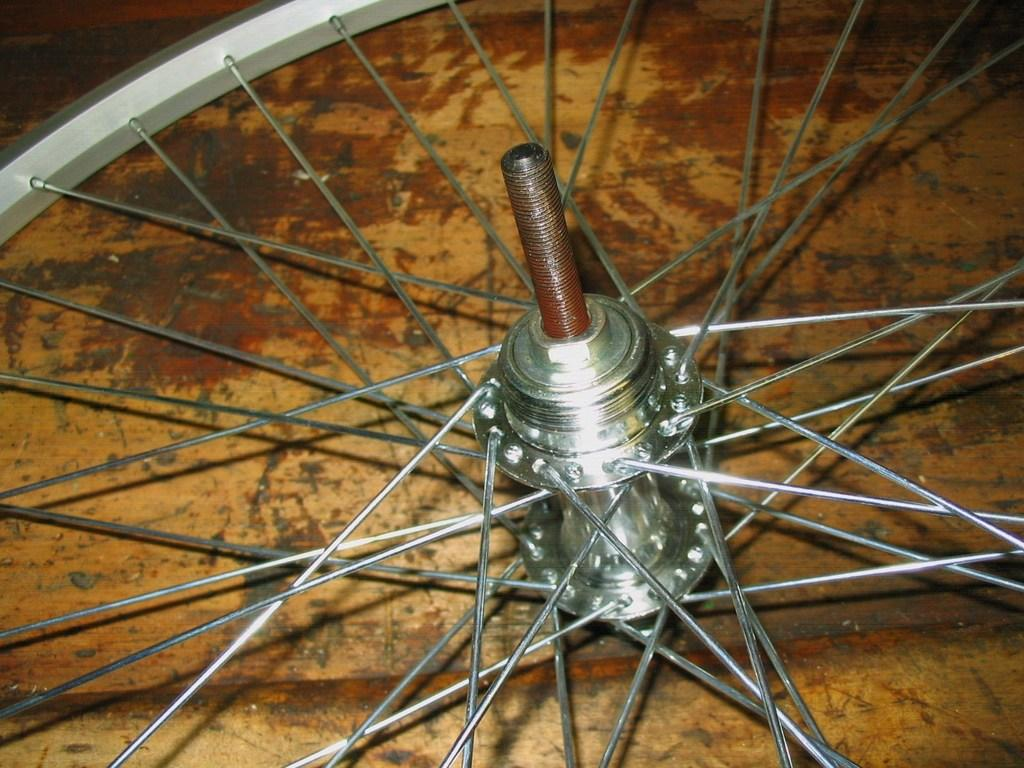What object is the main focus of the image? The main focus of the image is a wheel of a bicycle. Where is the bicycle wheel located? The wheel is on a platform. What type of knowledge is being shared by the passenger in the image? There is no passenger present in the image, and therefore no knowledge being shared. 